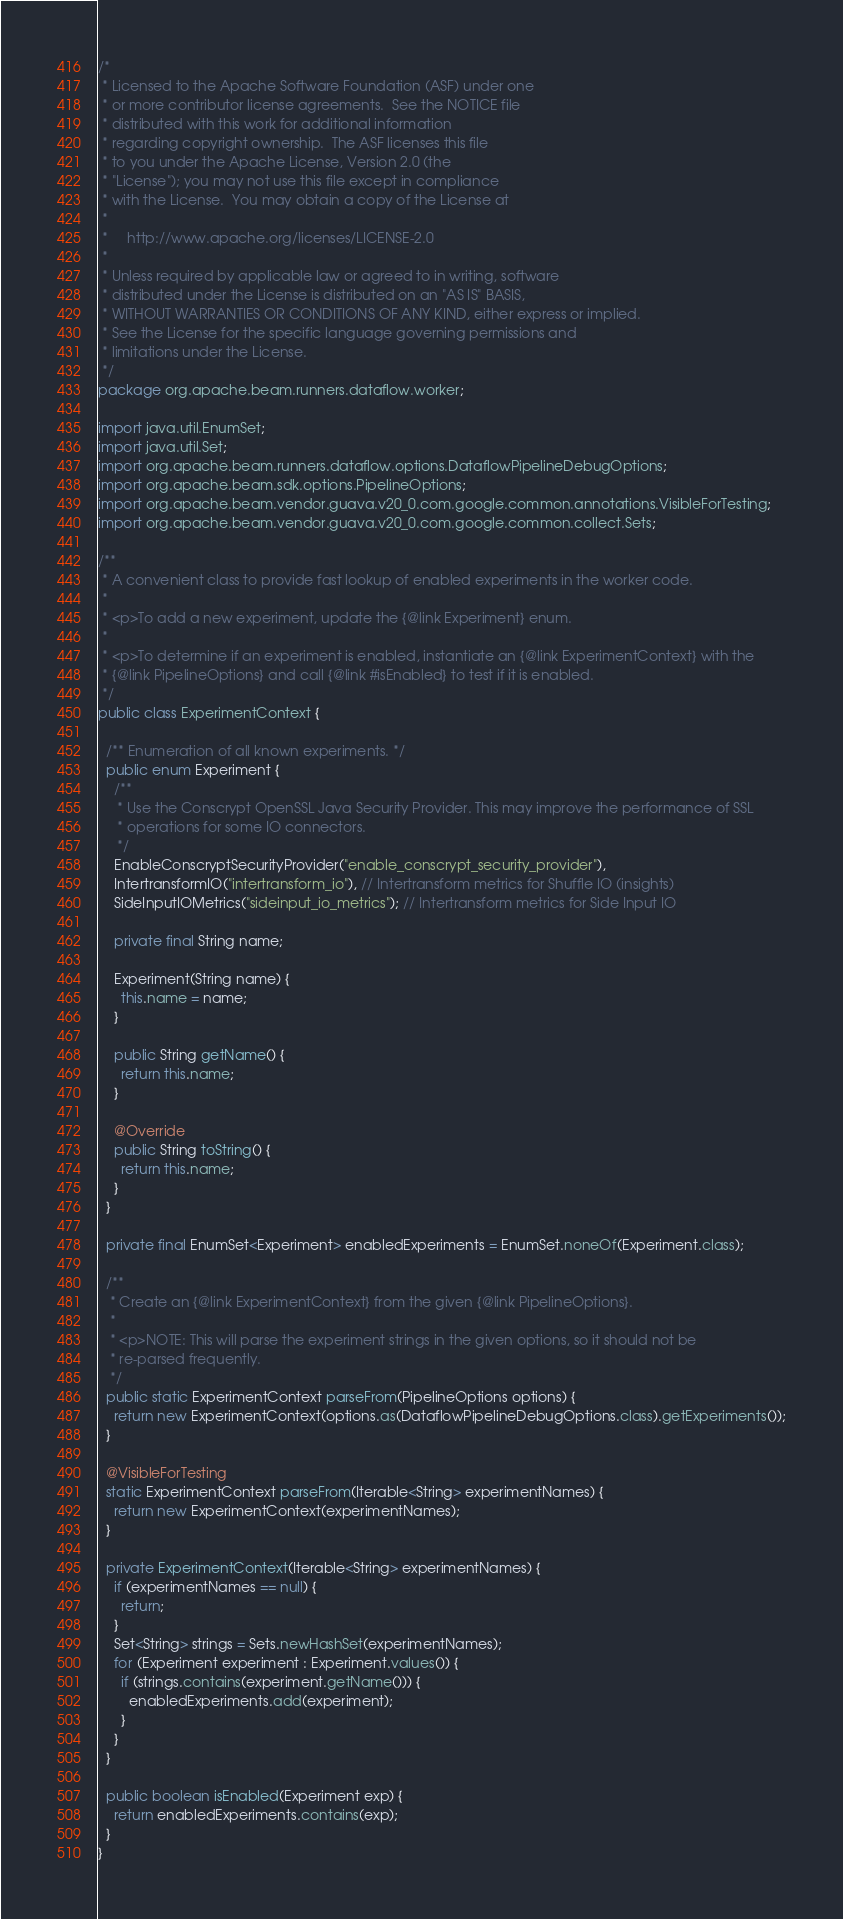Convert code to text. <code><loc_0><loc_0><loc_500><loc_500><_Java_>/*
 * Licensed to the Apache Software Foundation (ASF) under one
 * or more contributor license agreements.  See the NOTICE file
 * distributed with this work for additional information
 * regarding copyright ownership.  The ASF licenses this file
 * to you under the Apache License, Version 2.0 (the
 * "License"); you may not use this file except in compliance
 * with the License.  You may obtain a copy of the License at
 *
 *     http://www.apache.org/licenses/LICENSE-2.0
 *
 * Unless required by applicable law or agreed to in writing, software
 * distributed under the License is distributed on an "AS IS" BASIS,
 * WITHOUT WARRANTIES OR CONDITIONS OF ANY KIND, either express or implied.
 * See the License for the specific language governing permissions and
 * limitations under the License.
 */
package org.apache.beam.runners.dataflow.worker;

import java.util.EnumSet;
import java.util.Set;
import org.apache.beam.runners.dataflow.options.DataflowPipelineDebugOptions;
import org.apache.beam.sdk.options.PipelineOptions;
import org.apache.beam.vendor.guava.v20_0.com.google.common.annotations.VisibleForTesting;
import org.apache.beam.vendor.guava.v20_0.com.google.common.collect.Sets;

/**
 * A convenient class to provide fast lookup of enabled experiments in the worker code.
 *
 * <p>To add a new experiment, update the {@link Experiment} enum.
 *
 * <p>To determine if an experiment is enabled, instantiate an {@link ExperimentContext} with the
 * {@link PipelineOptions} and call {@link #isEnabled} to test if it is enabled.
 */
public class ExperimentContext {

  /** Enumeration of all known experiments. */
  public enum Experiment {
    /**
     * Use the Conscrypt OpenSSL Java Security Provider. This may improve the performance of SSL
     * operations for some IO connectors.
     */
    EnableConscryptSecurityProvider("enable_conscrypt_security_provider"),
    IntertransformIO("intertransform_io"), // Intertransform metrics for Shuffle IO (insights)
    SideInputIOMetrics("sideinput_io_metrics"); // Intertransform metrics for Side Input IO

    private final String name;

    Experiment(String name) {
      this.name = name;
    }

    public String getName() {
      return this.name;
    }

    @Override
    public String toString() {
      return this.name;
    }
  }

  private final EnumSet<Experiment> enabledExperiments = EnumSet.noneOf(Experiment.class);

  /**
   * Create an {@link ExperimentContext} from the given {@link PipelineOptions}.
   *
   * <p>NOTE: This will parse the experiment strings in the given options, so it should not be
   * re-parsed frequently.
   */
  public static ExperimentContext parseFrom(PipelineOptions options) {
    return new ExperimentContext(options.as(DataflowPipelineDebugOptions.class).getExperiments());
  }

  @VisibleForTesting
  static ExperimentContext parseFrom(Iterable<String> experimentNames) {
    return new ExperimentContext(experimentNames);
  }

  private ExperimentContext(Iterable<String> experimentNames) {
    if (experimentNames == null) {
      return;
    }
    Set<String> strings = Sets.newHashSet(experimentNames);
    for (Experiment experiment : Experiment.values()) {
      if (strings.contains(experiment.getName())) {
        enabledExperiments.add(experiment);
      }
    }
  }

  public boolean isEnabled(Experiment exp) {
    return enabledExperiments.contains(exp);
  }
}
</code> 